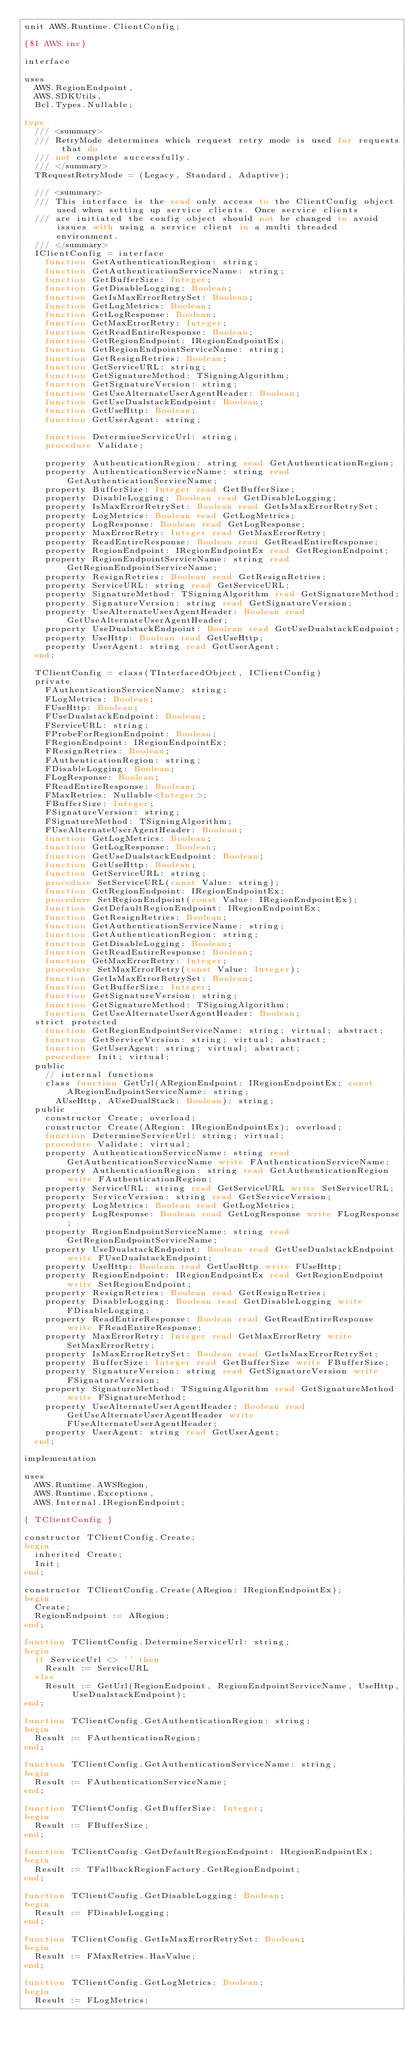<code> <loc_0><loc_0><loc_500><loc_500><_Pascal_>unit AWS.Runtime.ClientConfig;

{$I AWS.inc}

interface

uses
  AWS.RegionEndpoint,
  AWS.SDKUtils,
  Bcl.Types.Nullable;

type
  /// <summary>
  /// RetryMode determines which request retry mode is used for requests that do
  /// not complete successfully.
  /// </summary>
  TRequestRetryMode = (Legacy, Standard, Adaptive);

  /// <summary>
  /// This interface is the read only access to the ClientConfig object used when setting up service clients. Once service clients
  /// are initiated the config object should not be changed to avoid issues with using a service client in a multi threaded environment.
  /// </summary>
  IClientConfig = interface
    function GetAuthenticationRegion: string;
    function GetAuthenticationServiceName: string;
    function GetBufferSize: Integer;
    function GetDisableLogging: Boolean;
    function GetIsMaxErrorRetrySet: Boolean;
    function GetLogMetrics: Boolean;
    function GetLogResponse: Boolean;
    function GetMaxErrorRetry: Integer;
    function GetReadEntireResponse: Boolean;
    function GetRegionEndpoint: IRegionEndpointEx;
    function GetRegionEndpointServiceName: string;
    function GetResignRetries: Boolean;
    function GetServiceURL: string;
    function GetSignatureMethod: TSigningAlgorithm;
    function GetSignatureVersion: string;
    function GetUseAlternateUserAgentHeader: Boolean;
    function GetUseDualstackEndpoint: Boolean;
    function GetUseHttp: Boolean;
    function GetUserAgent: string;

    function DetermineServiceUrl: string;
    procedure Validate;

    property AuthenticationRegion: string read GetAuthenticationRegion;
    property AuthenticationServiceName: string read GetAuthenticationServiceName;
    property BufferSize: Integer read GetBufferSize;
    property DisableLogging: Boolean read GetDisableLogging;
    property IsMaxErrorRetrySet: Boolean read GetIsMaxErrorRetrySet;
    property LogMetrics: Boolean read GetLogMetrics;
    property LogResponse: Boolean read GetLogResponse;
    property MaxErrorRetry: Integer read GetMaxErrorRetry;
    property ReadEntireResponse: Boolean read GetReadEntireResponse;
    property RegionEndpoint: IRegionEndpointEx read GetRegionEndpoint;
    property RegionEndpointServiceName: string read GetRegionEndpointServiceName;
    property ResignRetries: Boolean read GetResignRetries;
    property ServiceURL: string read GetServiceURL;
    property SignatureMethod: TSigningAlgorithm read GetSignatureMethod;
    property SignatureVersion: string read GetSignatureVersion;
    property UseAlternateUserAgentHeader: Boolean read GetUseAlternateUserAgentHeader;
    property UseDualstackEndpoint: Boolean read GetUseDualstackEndpoint;
    property UseHttp: Boolean read GetUseHttp;
    property UserAgent: string read GetUserAgent;
  end;

  TClientConfig = class(TInterfacedObject, IClientConfig)
  private
    FAuthenticationServiceName: string;
    FLogMetrics: Boolean;
    FUseHttp: Boolean;
    FUseDualstackEndpoint: Boolean;
    FServiceURL: string;
    FProbeForRegionEndpoint: Boolean;
    FRegionEndpoint: IRegionEndpointEx;
    FResignRetries: Boolean;
    FAuthenticationRegion: string;
    FDisableLogging: Boolean;
    FLogResponse: Boolean;
    FReadEntireResponse: Boolean;
    FMaxRetries: Nullable<Integer>;
    FBufferSize: Integer;
    FSignatureVersion: string;
    FSignatureMethod: TSigningAlgorithm;
    FUseAlternateUserAgentHeader: Boolean;
    function GetLogMetrics: Boolean;
    function GetLogResponse: Boolean;
    function GetUseDualstackEndpoint: Boolean;
    function GetUseHttp: Boolean;
    function GetServiceURL: string;
    procedure SetServiceURL(const Value: string);
    function GetRegionEndpoint: IRegionEndpointEx;
    procedure SetRegionEndpoint(const Value: IRegionEndpointEx);
    function GetDefaultRegionEndpoint: IRegionEndpointEx;
    function GetResignRetries: Boolean;
    function GetAuthenticationServiceName: string;
    function GetAuthenticationRegion: string;
    function GetDisableLogging: Boolean;
    function GetReadEntireResponse: Boolean;
    function GetMaxErrorRetry: Integer;
    procedure SetMaxErrorRetry(const Value: Integer);
    function GetIsMaxErrorRetrySet: Boolean;
    function GetBufferSize: Integer;
    function GetSignatureVersion: string;
    function GetSignatureMethod: TSigningAlgorithm;
    function GetUseAlternateUserAgentHeader: Boolean;
  strict protected
    function GetRegionEndpointServiceName: string; virtual; abstract;
    function GetServiceVersion: string; virtual; abstract;
    function GetUserAgent: string; virtual; abstract;
    procedure Init; virtual;
  public
    // internal functions
    class function GetUrl(ARegionEndpoint: IRegionEndpointEx; const ARegionEndpointServiceName: string;
      AUseHttp, AUseDualStack: Boolean): string;
  public
    constructor Create; overload;
    constructor Create(ARegion: IRegionEndpointEx); overload;
    function DetermineServiceUrl: string; virtual;
    procedure Validate; virtual;
    property AuthenticationServiceName: string read GetAuthenticationServiceName write FAuthenticationServiceName;
    property AuthenticationRegion: string read GetAuthenticationRegion write FAuthenticationRegion;
    property ServiceURL: string read GetServiceURL write SetServiceURL;
    property ServiceVersion: string read GetServiceVersion;
    property LogMetrics: Boolean read GetLogMetrics;
    property LogResponse: Boolean read GetLogResponse write FLogResponse;
    property RegionEndpointServiceName: string read GetRegionEndpointServiceName;
    property UseDualstackEndpoint: Boolean read GetUseDualstackEndpoint write FUseDualstackEndpoint;
    property UseHttp: Boolean read GetUseHttp write FUseHttp;
    property RegionEndpoint: IRegionEndpointEx read GetRegionEndpoint write SetRegionEndpoint;
    property ResignRetries: Boolean read GetResignRetries;
    property DisableLogging: Boolean read GetDisableLogging write FDisableLogging;
    property ReadEntireResponse: Boolean read GetReadEntireResponse write FReadEntireResponse;
    property MaxErrorRetry: Integer read GetMaxErrorRetry write SetMaxErrorRetry;
    property IsMaxErrorRetrySet: Boolean read GetIsMaxErrorRetrySet;
    property BufferSize: Integer read GetBufferSize write FBufferSize;
    property SignatureVersion: string read GetSignatureVersion write FSignatureVersion;
    property SignatureMethod: TSigningAlgorithm read GetSignatureMethod write FSignatureMethod;
    property UseAlternateUserAgentHeader: Boolean read GetUseAlternateUserAgentHeader write FUseAlternateUserAgentHeader;
    property UserAgent: string read GetUserAgent;
  end;

implementation

uses
  AWS.Runtime.AWSRegion,
  AWS.Runtime.Exceptions,
  AWS.Internal.IRegionEndpoint;

{ TClientConfig }

constructor TClientConfig.Create;
begin
  inherited Create;
  Init;
end;

constructor TClientConfig.Create(ARegion: IRegionEndpointEx);
begin
  Create;
  RegionEndpoint := ARegion;
end;

function TClientConfig.DetermineServiceUrl: string;
begin
  if ServiceUrl <> '' then
    Result := ServiceURL
  else
    Result := GetUrl(RegionEndpoint, RegionEndpointServiceName, UseHttp, UseDualstackEndpoint);
end;

function TClientConfig.GetAuthenticationRegion: string;
begin
  Result := FAuthenticationRegion;
end;

function TClientConfig.GetAuthenticationServiceName: string;
begin
  Result := FAuthenticationServiceName;
end;

function TClientConfig.GetBufferSize: Integer;
begin
  Result := FBufferSize;
end;

function TClientConfig.GetDefaultRegionEndpoint: IRegionEndpointEx;
begin
  Result := TFallbackRegionFactory.GetRegionEndpoint;
end;

function TClientConfig.GetDisableLogging: Boolean;
begin
  Result := FDisableLogging;
end;

function TClientConfig.GetIsMaxErrorRetrySet: Boolean;
begin
  Result := FMaxRetries.HasValue;
end;

function TClientConfig.GetLogMetrics: Boolean;
begin
  Result := FLogMetrics;</code> 